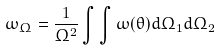Convert formula to latex. <formula><loc_0><loc_0><loc_500><loc_500>\omega _ { \Omega } = \frac { 1 } { \Omega ^ { 2 } } \int \int \omega ( \theta ) d \Omega _ { 1 } d \Omega _ { 2 }</formula> 